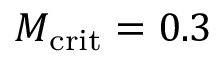Convert formula to latex. <formula><loc_0><loc_0><loc_500><loc_500>M _ { c r i t } = 0 . 3</formula> 